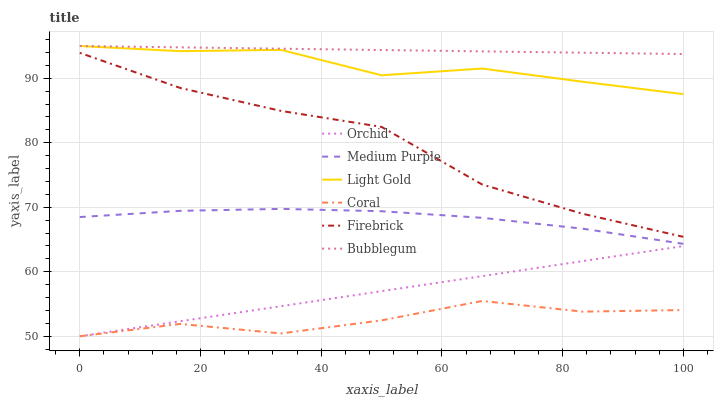Does Medium Purple have the minimum area under the curve?
Answer yes or no. No. Does Medium Purple have the maximum area under the curve?
Answer yes or no. No. Is Bubblegum the smoothest?
Answer yes or no. No. Is Bubblegum the roughest?
Answer yes or no. No. Does Medium Purple have the lowest value?
Answer yes or no. No. Does Medium Purple have the highest value?
Answer yes or no. No. Is Firebrick less than Bubblegum?
Answer yes or no. Yes. Is Light Gold greater than Orchid?
Answer yes or no. Yes. Does Firebrick intersect Bubblegum?
Answer yes or no. No. 